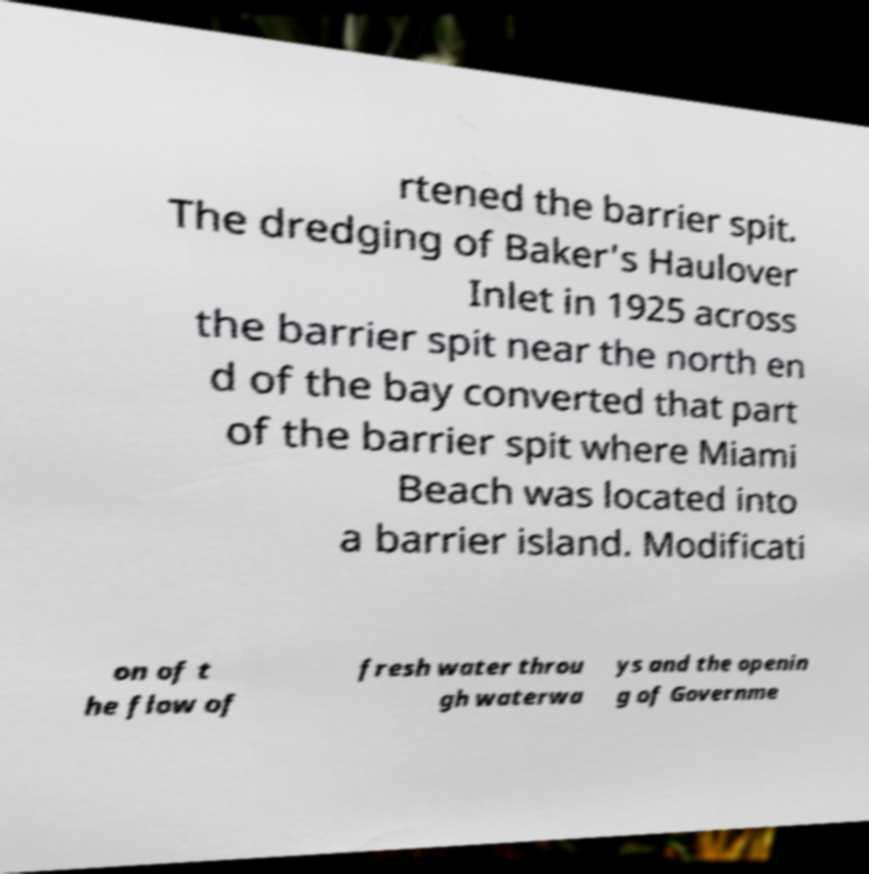Can you read and provide the text displayed in the image?This photo seems to have some interesting text. Can you extract and type it out for me? rtened the barrier spit. The dredging of Baker's Haulover Inlet in 1925 across the barrier spit near the north en d of the bay converted that part of the barrier spit where Miami Beach was located into a barrier island. Modificati on of t he flow of fresh water throu gh waterwa ys and the openin g of Governme 